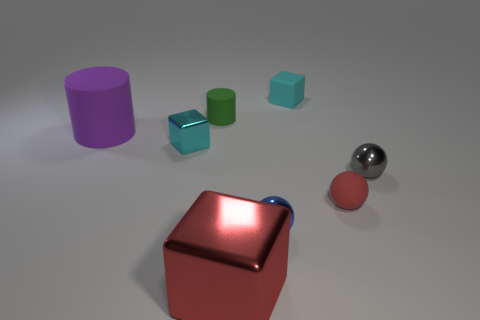Add 1 cyan metallic balls. How many objects exist? 9 Subtract all spheres. How many objects are left? 5 Add 4 small green rubber cylinders. How many small green rubber cylinders exist? 5 Subtract 1 green cylinders. How many objects are left? 7 Subtract all large yellow blocks. Subtract all small blocks. How many objects are left? 6 Add 8 small cylinders. How many small cylinders are left? 9 